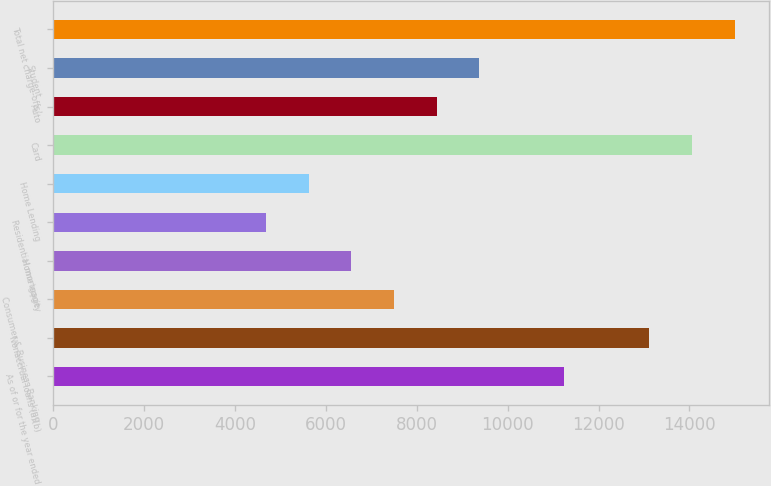<chart> <loc_0><loc_0><loc_500><loc_500><bar_chart><fcel>As of or for the year ended<fcel>Nonaccrual loans (a)(b)<fcel>Consumer & Business Banking<fcel>Home equity<fcel>Residential mortgage<fcel>Home Lending<fcel>Card<fcel>Auto<fcel>Student<fcel>Total net charge-offs/<nl><fcel>11246.4<fcel>13120.8<fcel>7497.62<fcel>6560.42<fcel>4686.02<fcel>5623.22<fcel>14058<fcel>8434.82<fcel>9372.02<fcel>14995.2<nl></chart> 